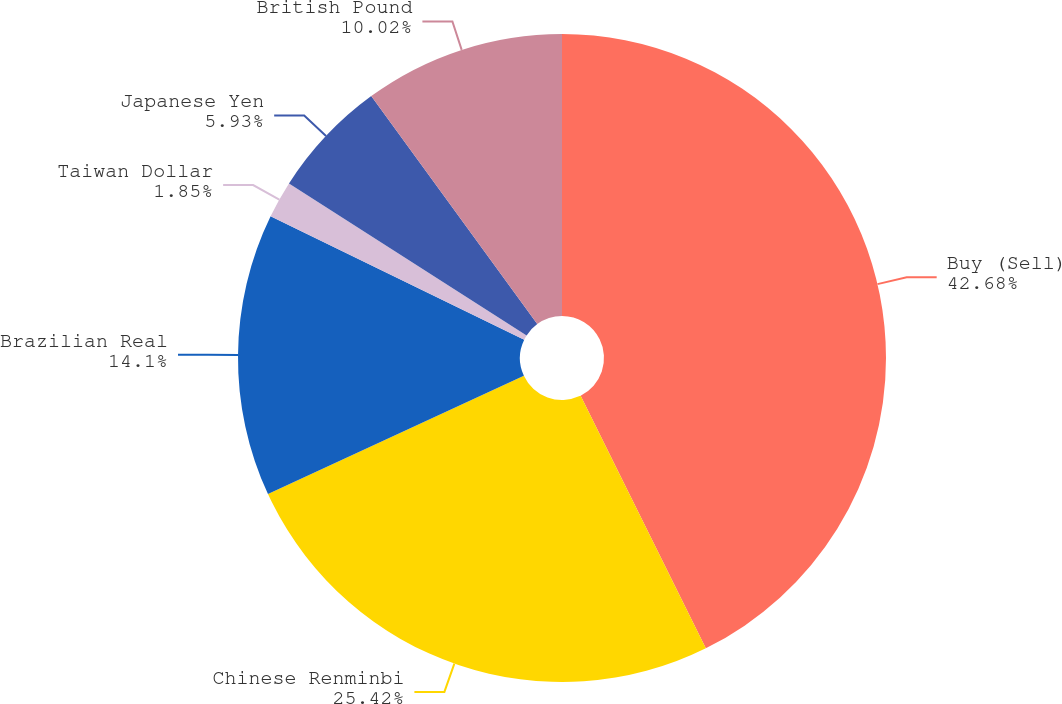<chart> <loc_0><loc_0><loc_500><loc_500><pie_chart><fcel>Buy (Sell)<fcel>Chinese Renminbi<fcel>Brazilian Real<fcel>Taiwan Dollar<fcel>Japanese Yen<fcel>British Pound<nl><fcel>42.68%<fcel>25.42%<fcel>14.1%<fcel>1.85%<fcel>5.93%<fcel>10.02%<nl></chart> 